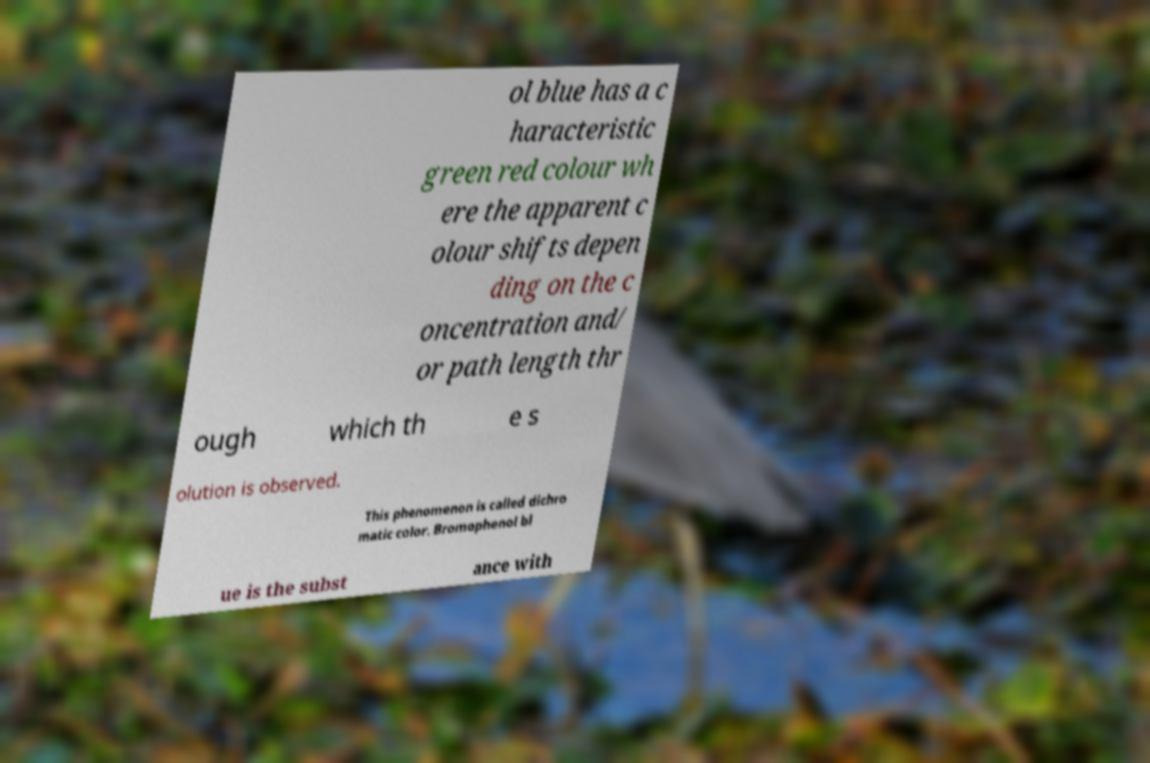Can you read and provide the text displayed in the image?This photo seems to have some interesting text. Can you extract and type it out for me? ol blue has a c haracteristic green red colour wh ere the apparent c olour shifts depen ding on the c oncentration and/ or path length thr ough which th e s olution is observed. This phenomenon is called dichro matic color. Bromophenol bl ue is the subst ance with 